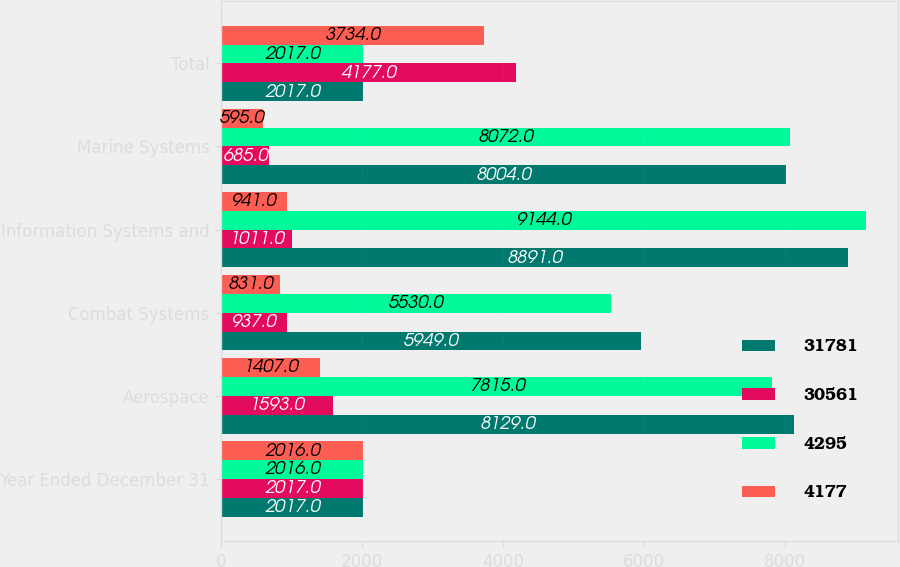Convert chart to OTSL. <chart><loc_0><loc_0><loc_500><loc_500><stacked_bar_chart><ecel><fcel>Year Ended December 31<fcel>Aerospace<fcel>Combat Systems<fcel>Information Systems and<fcel>Marine Systems<fcel>Total<nl><fcel>31781<fcel>2017<fcel>8129<fcel>5949<fcel>8891<fcel>8004<fcel>2017<nl><fcel>30561<fcel>2017<fcel>1593<fcel>937<fcel>1011<fcel>685<fcel>4177<nl><fcel>4295<fcel>2016<fcel>7815<fcel>5530<fcel>9144<fcel>8072<fcel>2017<nl><fcel>4177<fcel>2016<fcel>1407<fcel>831<fcel>941<fcel>595<fcel>3734<nl></chart> 